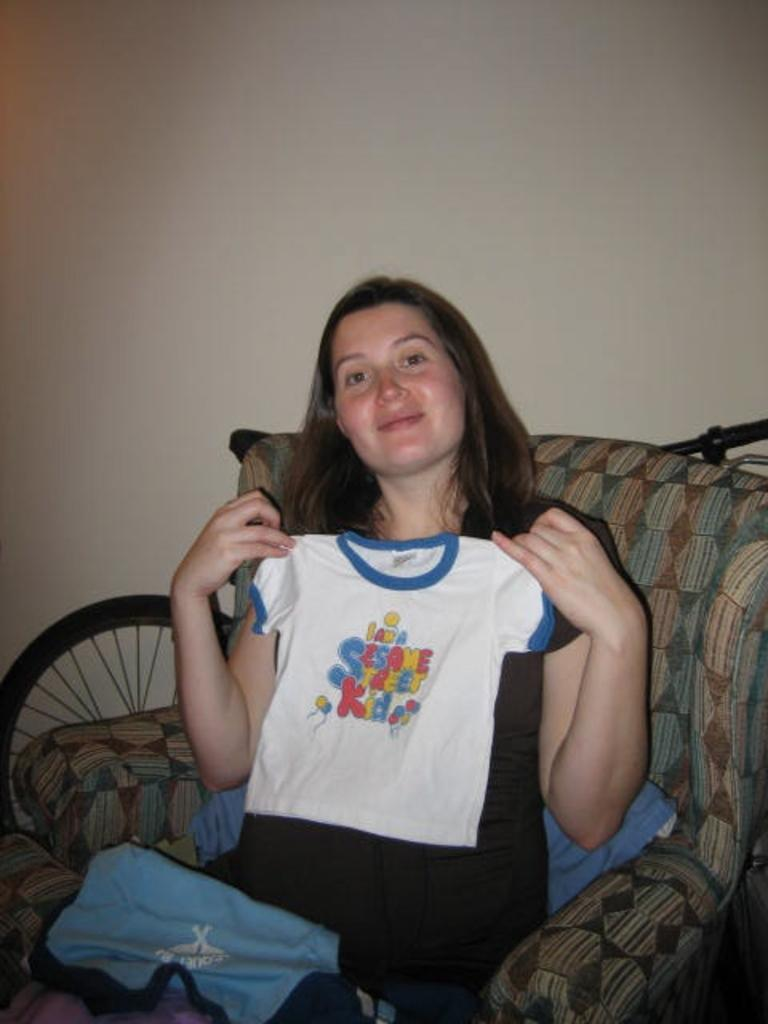What is the person in the image doing? The person is sitting on the couch in the image. What is the person holding in the image? The person is holding a white color shirt. What color is the wall in the image? The wall in the image is white. How many dimes can be seen on the person's grip in the image? There are no dimes visible in the image, and the person's grip is not mentioned in the facts provided. 